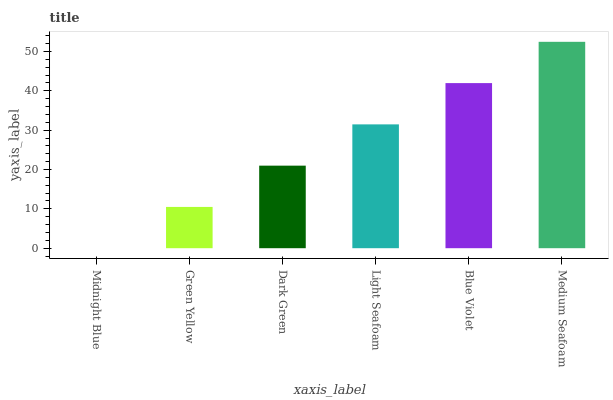Is Green Yellow the minimum?
Answer yes or no. No. Is Green Yellow the maximum?
Answer yes or no. No. Is Green Yellow greater than Midnight Blue?
Answer yes or no. Yes. Is Midnight Blue less than Green Yellow?
Answer yes or no. Yes. Is Midnight Blue greater than Green Yellow?
Answer yes or no. No. Is Green Yellow less than Midnight Blue?
Answer yes or no. No. Is Light Seafoam the high median?
Answer yes or no. Yes. Is Dark Green the low median?
Answer yes or no. Yes. Is Medium Seafoam the high median?
Answer yes or no. No. Is Midnight Blue the low median?
Answer yes or no. No. 